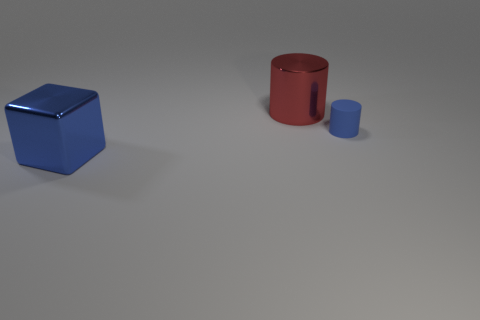Add 2 green shiny cylinders. How many objects exist? 5 Subtract all cylinders. How many objects are left? 1 Add 3 tiny blue cylinders. How many tiny blue cylinders are left? 4 Add 3 large metal cylinders. How many large metal cylinders exist? 4 Subtract 0 purple cubes. How many objects are left? 3 Subtract all purple blocks. Subtract all tiny blue cylinders. How many objects are left? 2 